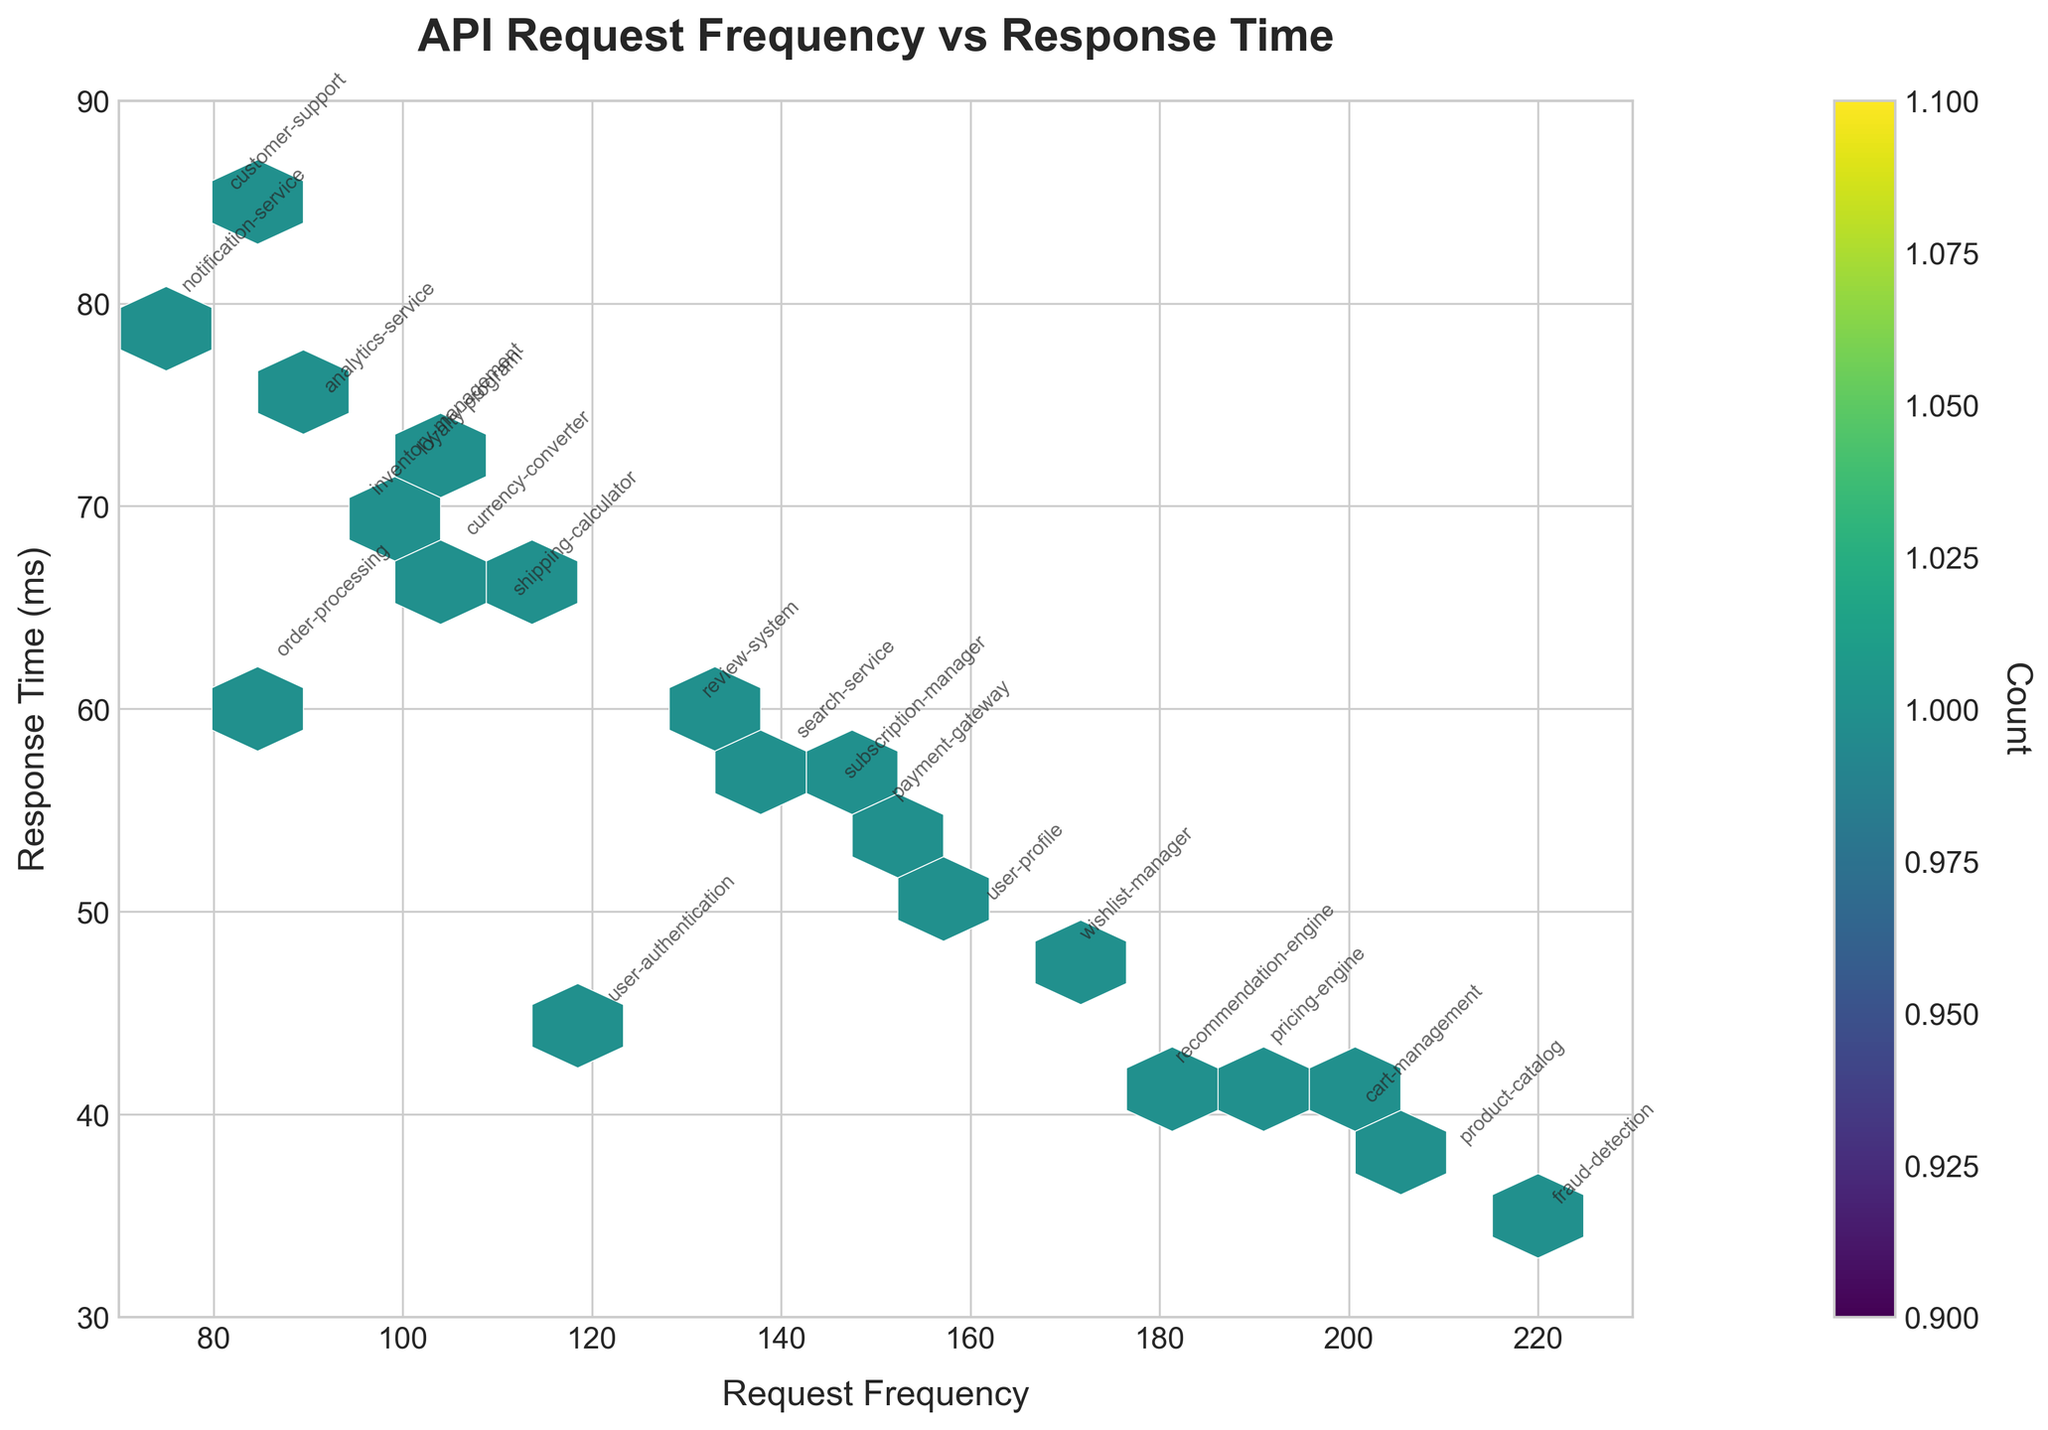What is the title of the figure? The title is usually located at the top of the figure. Here it reads 'API Request Frequency vs Response Time' in bold font.
Answer: API Request Frequency vs Response Time What do the x-axis and y-axis represent? The labels of the axes indicate their respective representations. The x-axis represents 'Request Frequency' and the y-axis represents 'Response Time (ms)'.
Answer: Request Frequency, Response Time (ms) What does the color intensity of a hexbin indicate in this plot? The color bar on the right side of the figure shows that the color intensity represents the count of overlapping data points in that specific bin. Darker colors indicate higher counts.
Answer: Count Which service has the highest request frequency? To find the highest, look at the x-axis values and find the data point farthest to the right. The 'fraud-detection' service has the highest request frequency at 220.
Answer: fraud-detection What is the response time for the 'notification-service'? Locate the annotation 'notification-service' on the plot and check its position on the y-axis. It is close to 80 ms.
Answer: 80 ms How does the 'fraud-detection' service's response time compare to 'product-catalog'? Find both annotations on the plot and compare their y-axis values. 'fraud-detection' is at 35 ms whereas 'product-catalog' is at 38 ms.
Answer: The 'fraud-detection' service has a slightly faster response time What is the average response time of all services? Sum all the response times: 45 + 62 + 38 + 55 + 70 + 42 + 58 + 80 + 40 + 65 + 50 + 75 + 60 + 48 + 72 + 43 + 85 + 35 + 68 + 56 = 1207. With 20 services, the average response time is 1207/20 = 60.35 ms.
Answer: 60.35 ms Which service has the smallest request frequency? To find the smallest, look at the x-axis values and find the data point farthest to the left. The 'notification-service' has the smallest request frequency at 75.
Answer: notification-service What range do the response times fall into? Look at the y-axis range from the lowest to highest response time values, it ranges from 30 ms to 90 ms.
Answer: 30 ms to 90 ms Are there more services with response times above 60 ms or below 60 ms? Count the data points above and below the y-axis value of 60 ms:
Above 60 ms: notification-service, inventory-management, shipping-calculator, order-processing, user-profile, loyalty-program, currency-converter, analytics-service = 8
Below 60 ms: user-authentication, order-processing, product-catalog, payment-gateway, recommendation-engine, search-service, cart-management, review-system, wishlist-manager, pricing-engine, fraud-detection, subscription-manager = 12
There are more services with response times below 60 ms.
Answer: Below 60 ms 